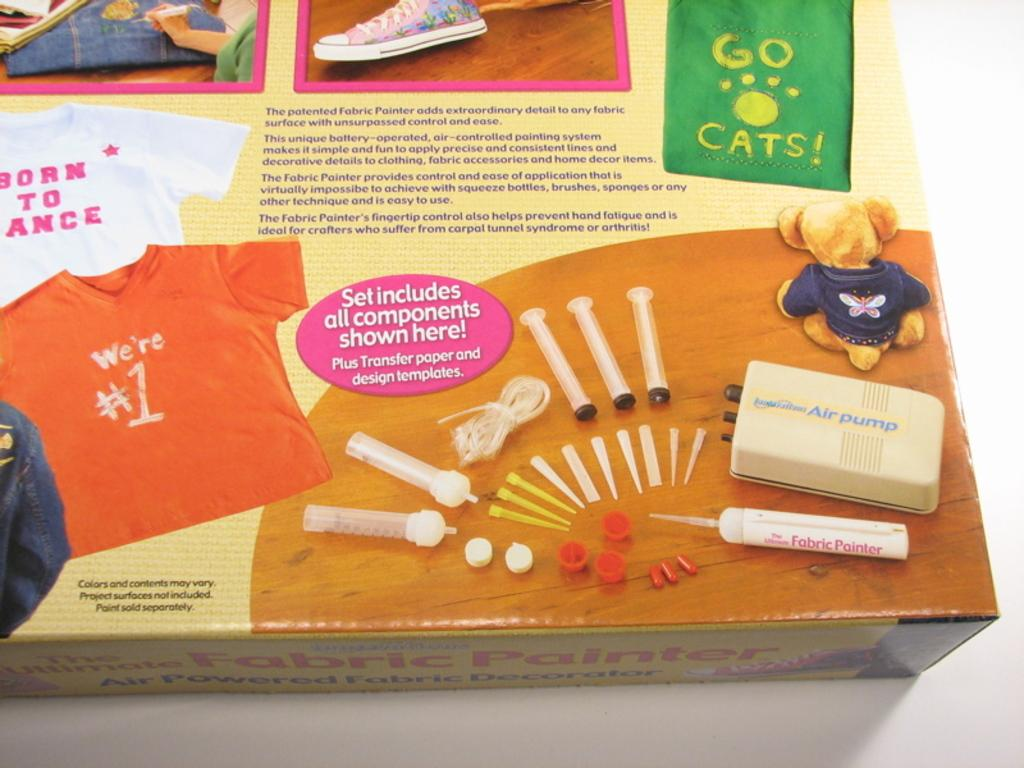What object is present in the image that has a rectangular shape? There is a cardboard box in the image. What can be seen on the surface of the box? The box has pictures and text on it. Where is the box located in the image? The box is on top of a table. What type of riddle is written on the plate in the image? There is no plate present in the image, and therefore no riddle can be found on it. 